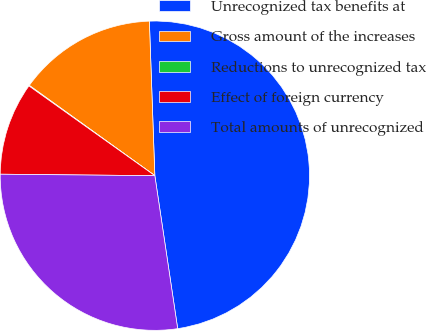Convert chart to OTSL. <chart><loc_0><loc_0><loc_500><loc_500><pie_chart><fcel>Unrecognized tax benefits at<fcel>Gross amount of the increases<fcel>Reductions to unrecognized tax<fcel>Effect of foreign currency<fcel>Total amounts of unrecognized<nl><fcel>48.2%<fcel>14.51%<fcel>0.07%<fcel>9.7%<fcel>27.51%<nl></chart> 